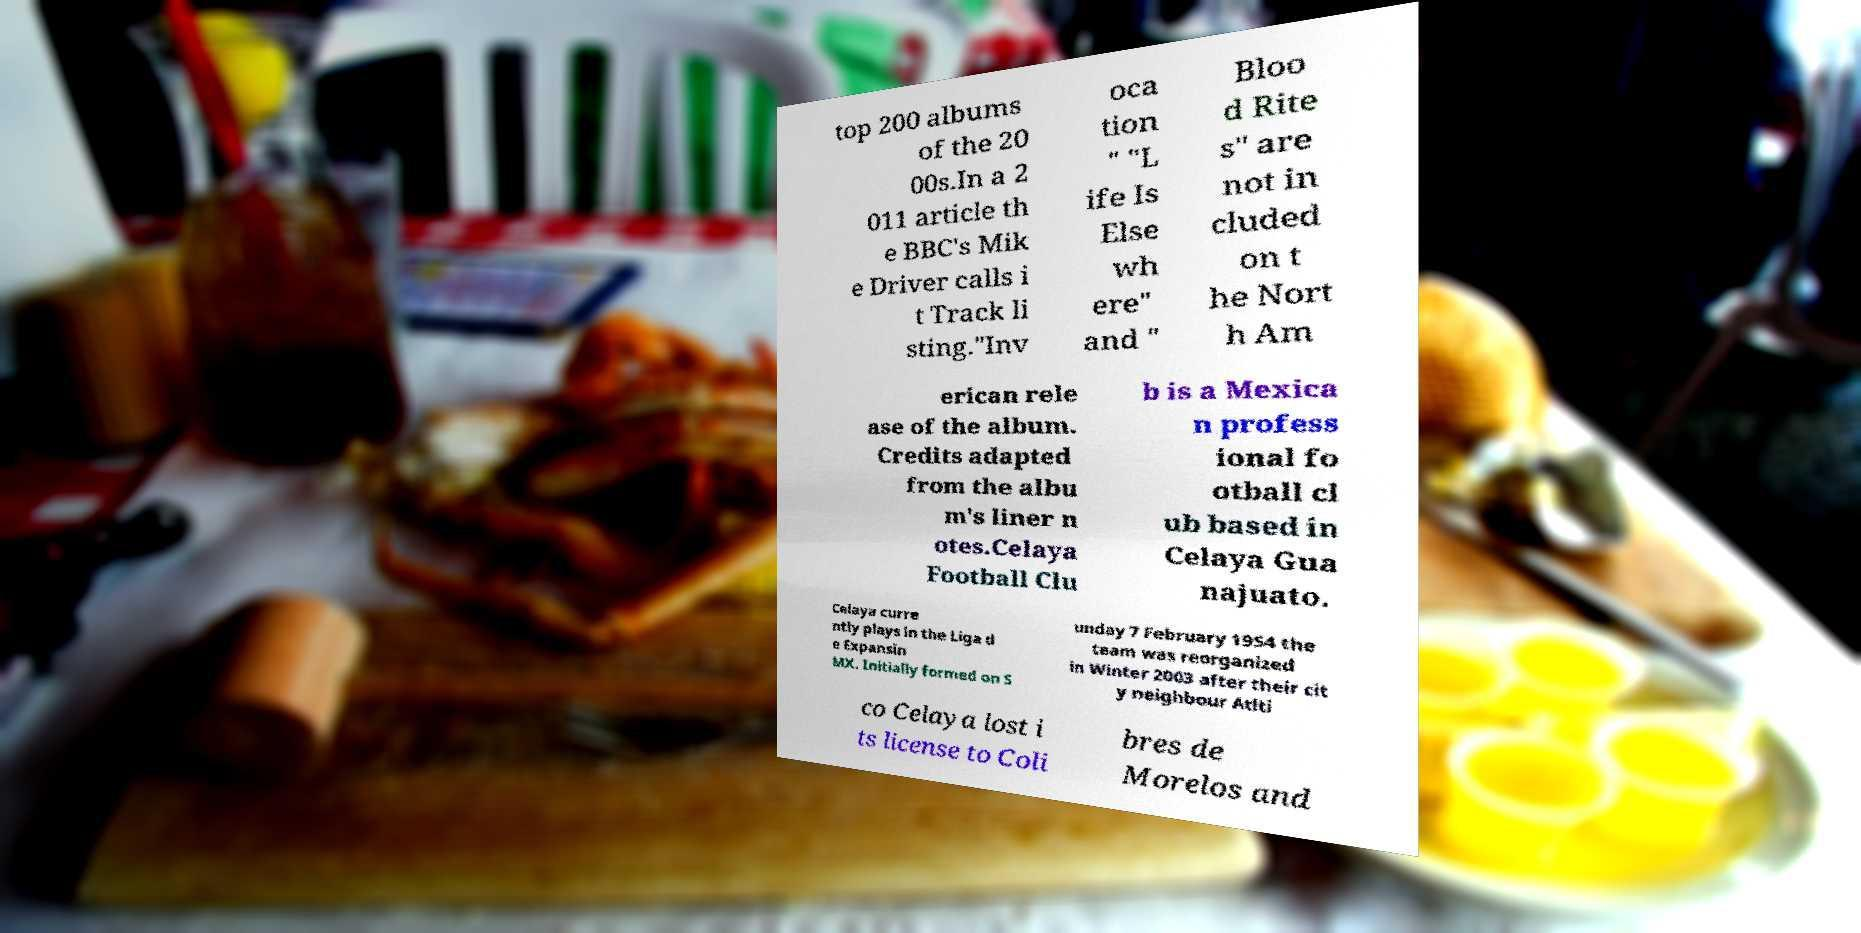I need the written content from this picture converted into text. Can you do that? top 200 albums of the 20 00s.In a 2 011 article th e BBC's Mik e Driver calls i t Track li sting."Inv oca tion " "L ife Is Else wh ere" and " Bloo d Rite s" are not in cluded on t he Nort h Am erican rele ase of the album. Credits adapted from the albu m's liner n otes.Celaya Football Clu b is a Mexica n profess ional fo otball cl ub based in Celaya Gua najuato. Celaya curre ntly plays in the Liga d e Expansin MX. Initially formed on S unday 7 February 1954 the team was reorganized in Winter 2003 after their cit y neighbour Atlti co Celaya lost i ts license to Coli bres de Morelos and 